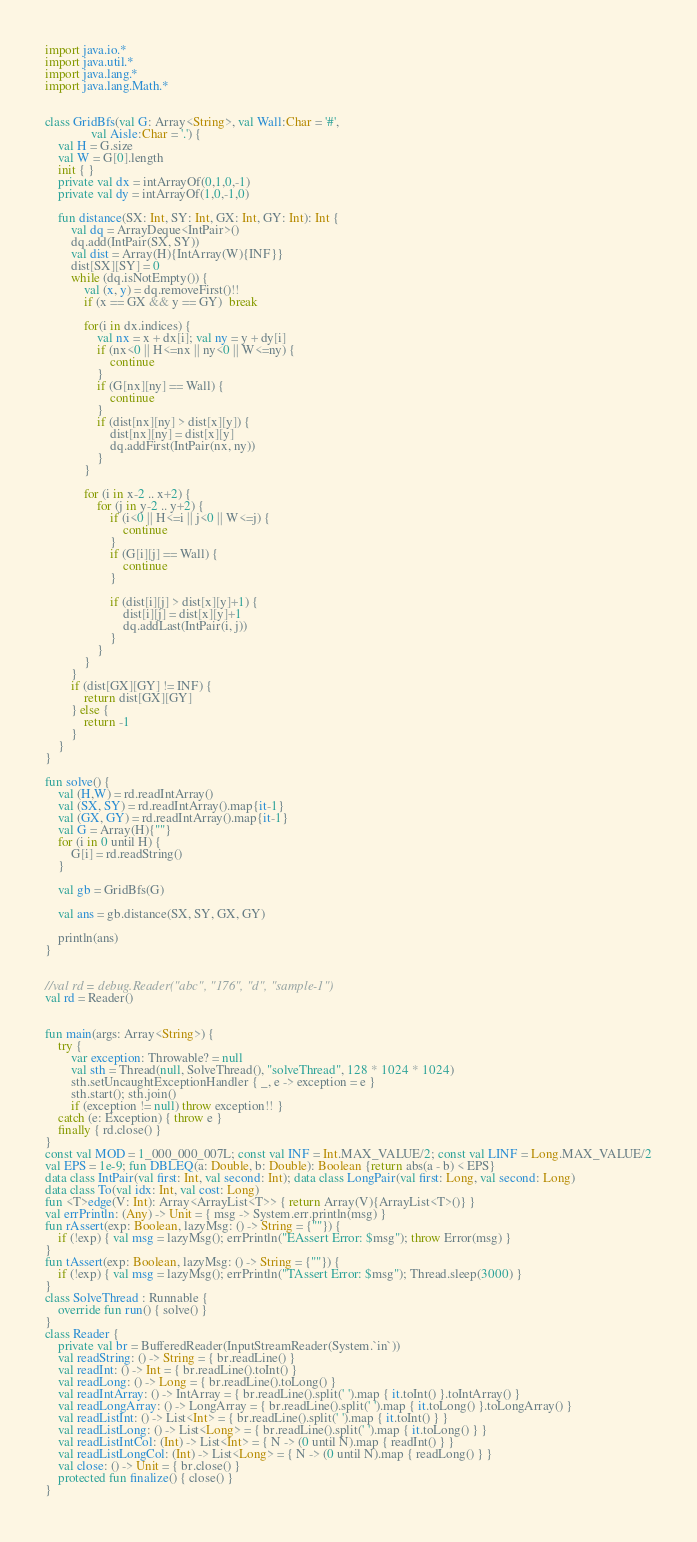<code> <loc_0><loc_0><loc_500><loc_500><_Kotlin_>import java.io.*
import java.util.*
import java.lang.*
import java.lang.Math.*


class GridBfs(val G: Array<String>, val Wall:Char = '#',
              val Aisle:Char = '.') {
    val H = G.size
    val W = G[0].length
    init { }
    private val dx = intArrayOf(0,1,0,-1)
    private val dy = intArrayOf(1,0,-1,0)

    fun distance(SX: Int, SY: Int, GX: Int, GY: Int): Int {
        val dq = ArrayDeque<IntPair>()
        dq.add(IntPair(SX, SY))
        val dist = Array(H){IntArray(W){INF}}
        dist[SX][SY] = 0
        while (dq.isNotEmpty()) {
            val (x, y) = dq.removeFirst()!!
            if (x == GX && y == GY)  break

            for(i in dx.indices) {
                val nx = x + dx[i]; val ny = y + dy[i]
                if (nx<0 || H<=nx || ny<0 || W<=ny) {
                    continue
                }
                if (G[nx][ny] == Wall) {
                    continue
                }
                if (dist[nx][ny] > dist[x][y]) {
                    dist[nx][ny] = dist[x][y]
                    dq.addFirst(IntPair(nx, ny))
                }
            }

            for (i in x-2 .. x+2) {
                for (j in y-2 .. y+2) {
                    if (i<0 || H<=i || j<0 || W<=j) {
                        continue
                    }
                    if (G[i][j] == Wall) {
                        continue
                    }

                    if (dist[i][j] > dist[x][y]+1) {
                        dist[i][j] = dist[x][y]+1
                        dq.addLast(IntPair(i, j))
                    }
                }
            }
        }
        if (dist[GX][GY] != INF) {
            return dist[GX][GY]
        } else {
            return -1
        }
    }
}

fun solve() {
    val (H,W) = rd.readIntArray()
    val (SX, SY) = rd.readIntArray().map{it-1}
    val (GX, GY) = rd.readIntArray().map{it-1}
    val G = Array(H){""}
    for (i in 0 until H) {
        G[i] = rd.readString()
    }

    val gb = GridBfs(G)

    val ans = gb.distance(SX, SY, GX, GY)

    println(ans)
}


//val rd = debug.Reader("abc", "176", "d", "sample-1")
val rd = Reader()


fun main(args: Array<String>) {
    try {
        var exception: Throwable? = null
        val sth = Thread(null, SolveThread(), "solveThread", 128 * 1024 * 1024)
        sth.setUncaughtExceptionHandler { _, e -> exception = e }
        sth.start(); sth.join()
        if (exception != null) throw exception!! }
    catch (e: Exception) { throw e }
    finally { rd.close() }
}
const val MOD = 1_000_000_007L; const val INF = Int.MAX_VALUE/2; const val LINF = Long.MAX_VALUE/2
val EPS = 1e-9; fun DBLEQ(a: Double, b: Double): Boolean {return abs(a - b) < EPS}
data class IntPair(val first: Int, val second: Int); data class LongPair(val first: Long, val second: Long)
data class To(val idx: Int, val cost: Long)
fun <T>edge(V: Int): Array<ArrayList<T>> { return Array(V){ArrayList<T>()} }
val errPrintln: (Any) -> Unit = { msg -> System.err.println(msg) }
fun rAssert(exp: Boolean, lazyMsg: () -> String = {""}) {
    if (!exp) { val msg = lazyMsg(); errPrintln("EAssert Error: $msg"); throw Error(msg) }
}
fun tAssert(exp: Boolean, lazyMsg: () -> String = {""}) {
    if (!exp) { val msg = lazyMsg(); errPrintln("TAssert Error: $msg"); Thread.sleep(3000) }
}
class SolveThread : Runnable {
    override fun run() { solve() }
}
class Reader {
    private val br = BufferedReader(InputStreamReader(System.`in`))
    val readString: () -> String = { br.readLine() }
    val readInt: () -> Int = { br.readLine().toInt() }
    val readLong: () -> Long = { br.readLine().toLong() }
    val readIntArray: () -> IntArray = { br.readLine().split(' ').map { it.toInt() }.toIntArray() }
    val readLongArray: () -> LongArray = { br.readLine().split(' ').map { it.toLong() }.toLongArray() }
    val readListInt: () -> List<Int> = { br.readLine().split(' ').map { it.toInt() } }
    val readListLong: () -> List<Long> = { br.readLine().split(' ').map { it.toLong() } }
    val readListIntCol: (Int) -> List<Int> = { N -> (0 until N).map { readInt() } }
    val readListLongCol: (Int) -> List<Long> = { N -> (0 until N).map { readLong() } }
    val close: () -> Unit = { br.close() }
    protected fun finalize() { close() }
}
</code> 